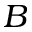<formula> <loc_0><loc_0><loc_500><loc_500>B</formula> 